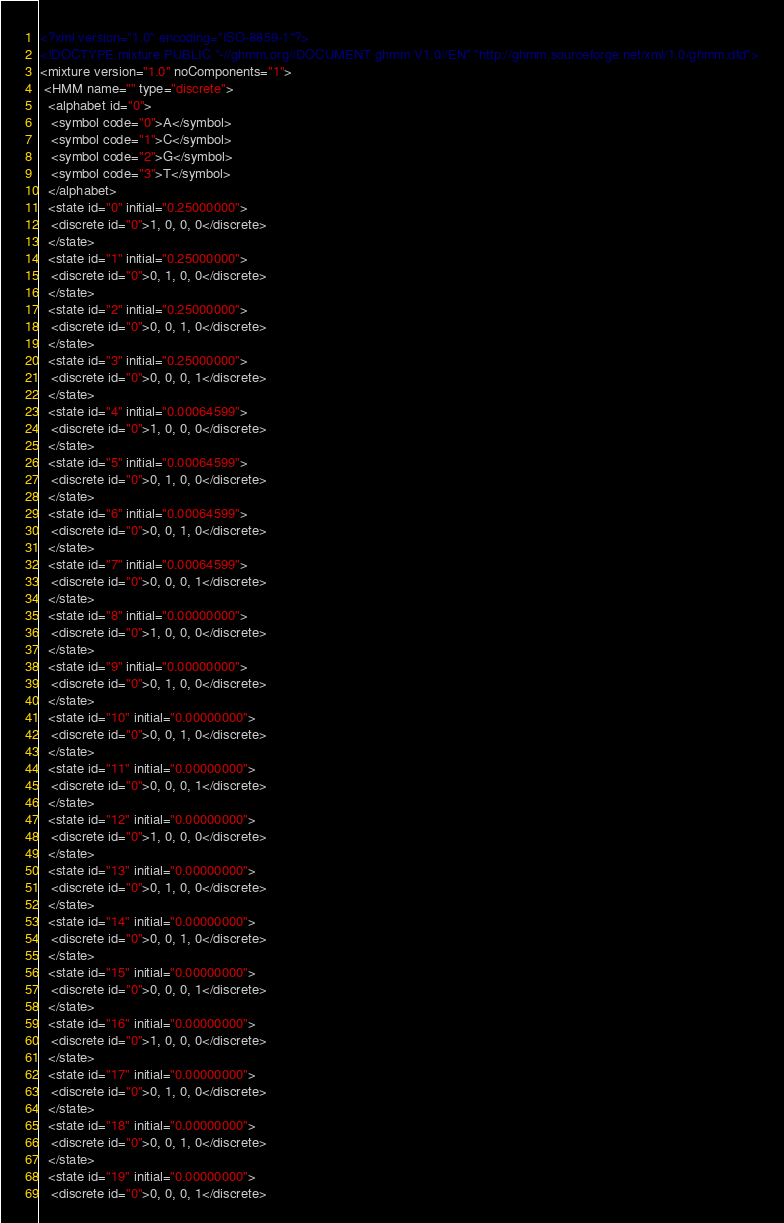Convert code to text. <code><loc_0><loc_0><loc_500><loc_500><_XML_><?xml version="1.0" encoding="ISO-8859-1"?>
<!DOCTYPE mixture PUBLIC "-//ghmm.org//DOCUMENT ghmm V1.0//EN" "http://ghmm.sourceforge.net/xml/1.0/ghmm.dtd">
<mixture version="1.0" noComponents="1">
 <HMM name="" type="discrete">
  <alphabet id="0">
   <symbol code="0">A</symbol>
   <symbol code="1">C</symbol>
   <symbol code="2">G</symbol>
   <symbol code="3">T</symbol>
  </alphabet>
  <state id="0" initial="0.25000000">
   <discrete id="0">1, 0, 0, 0</discrete>
  </state>
  <state id="1" initial="0.25000000">
   <discrete id="0">0, 1, 0, 0</discrete>
  </state>
  <state id="2" initial="0.25000000">
   <discrete id="0">0, 0, 1, 0</discrete>
  </state>
  <state id="3" initial="0.25000000">
   <discrete id="0">0, 0, 0, 1</discrete>
  </state>
  <state id="4" initial="0.00064599">
   <discrete id="0">1, 0, 0, 0</discrete>
  </state>
  <state id="5" initial="0.00064599">
   <discrete id="0">0, 1, 0, 0</discrete>
  </state>
  <state id="6" initial="0.00064599">
   <discrete id="0">0, 0, 1, 0</discrete>
  </state>
  <state id="7" initial="0.00064599">
   <discrete id="0">0, 0, 0, 1</discrete>
  </state>
  <state id="8" initial="0.00000000">
   <discrete id="0">1, 0, 0, 0</discrete>
  </state>
  <state id="9" initial="0.00000000">
   <discrete id="0">0, 1, 0, 0</discrete>
  </state>
  <state id="10" initial="0.00000000">
   <discrete id="0">0, 0, 1, 0</discrete>
  </state>
  <state id="11" initial="0.00000000">
   <discrete id="0">0, 0, 0, 1</discrete>
  </state>
  <state id="12" initial="0.00000000">
   <discrete id="0">1, 0, 0, 0</discrete>
  </state>
  <state id="13" initial="0.00000000">
   <discrete id="0">0, 1, 0, 0</discrete>
  </state>
  <state id="14" initial="0.00000000">
   <discrete id="0">0, 0, 1, 0</discrete>
  </state>
  <state id="15" initial="0.00000000">
   <discrete id="0">0, 0, 0, 1</discrete>
  </state>
  <state id="16" initial="0.00000000">
   <discrete id="0">1, 0, 0, 0</discrete>
  </state>
  <state id="17" initial="0.00000000">
   <discrete id="0">0, 1, 0, 0</discrete>
  </state>
  <state id="18" initial="0.00000000">
   <discrete id="0">0, 0, 1, 0</discrete>
  </state>
  <state id="19" initial="0.00000000">
   <discrete id="0">0, 0, 0, 1</discrete></code> 